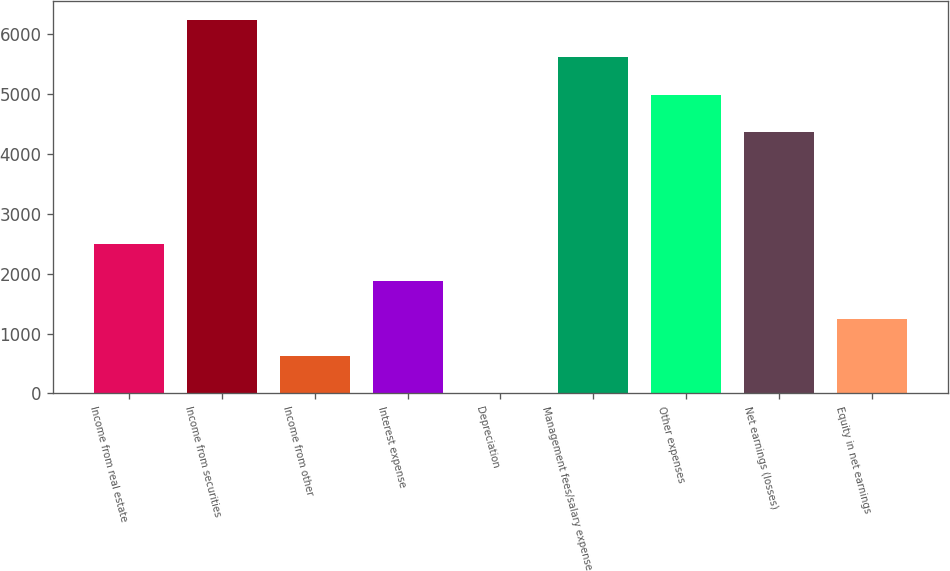<chart> <loc_0><loc_0><loc_500><loc_500><bar_chart><fcel>Income from real estate<fcel>Income from securities<fcel>Income from other<fcel>Interest expense<fcel>Depreciation<fcel>Management fees/salary expense<fcel>Other expenses<fcel>Net earnings (losses)<fcel>Equity in net earnings<nl><fcel>2495.8<fcel>6238<fcel>624.7<fcel>1872.1<fcel>1<fcel>5614.3<fcel>4990.6<fcel>4366.9<fcel>1248.4<nl></chart> 